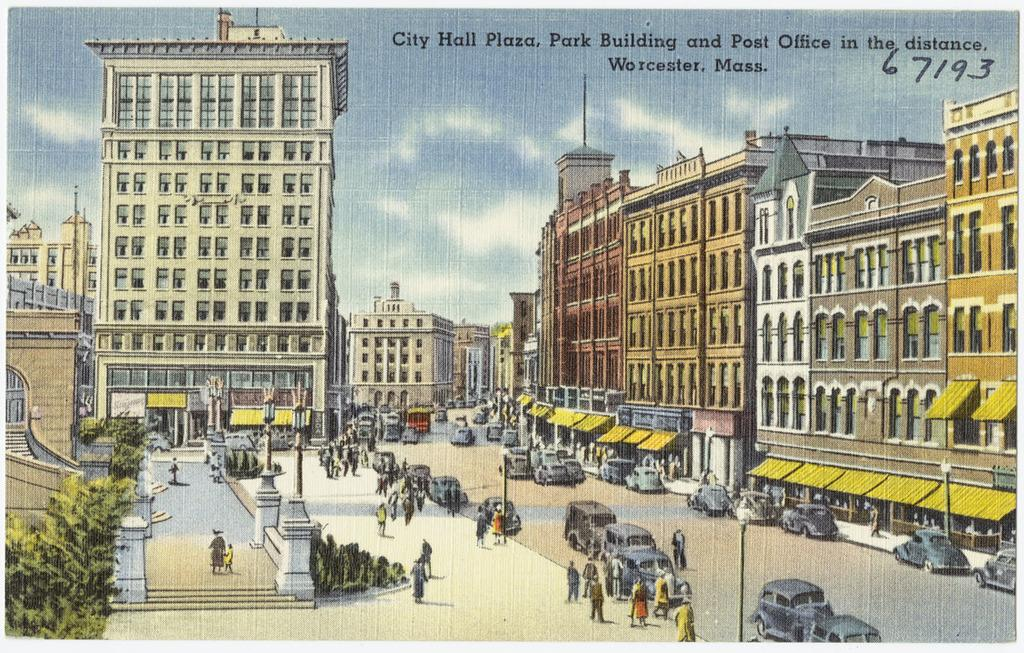What is the main subject of the image? The main subject of the image is a poster. What elements are included in the poster? The poster includes buildings, trees, poles, and people. What language is spoken by the people depicted in the poster? There is no indication of language spoken by the people in the poster, as it is a visual representation and does not include any audio or text. 